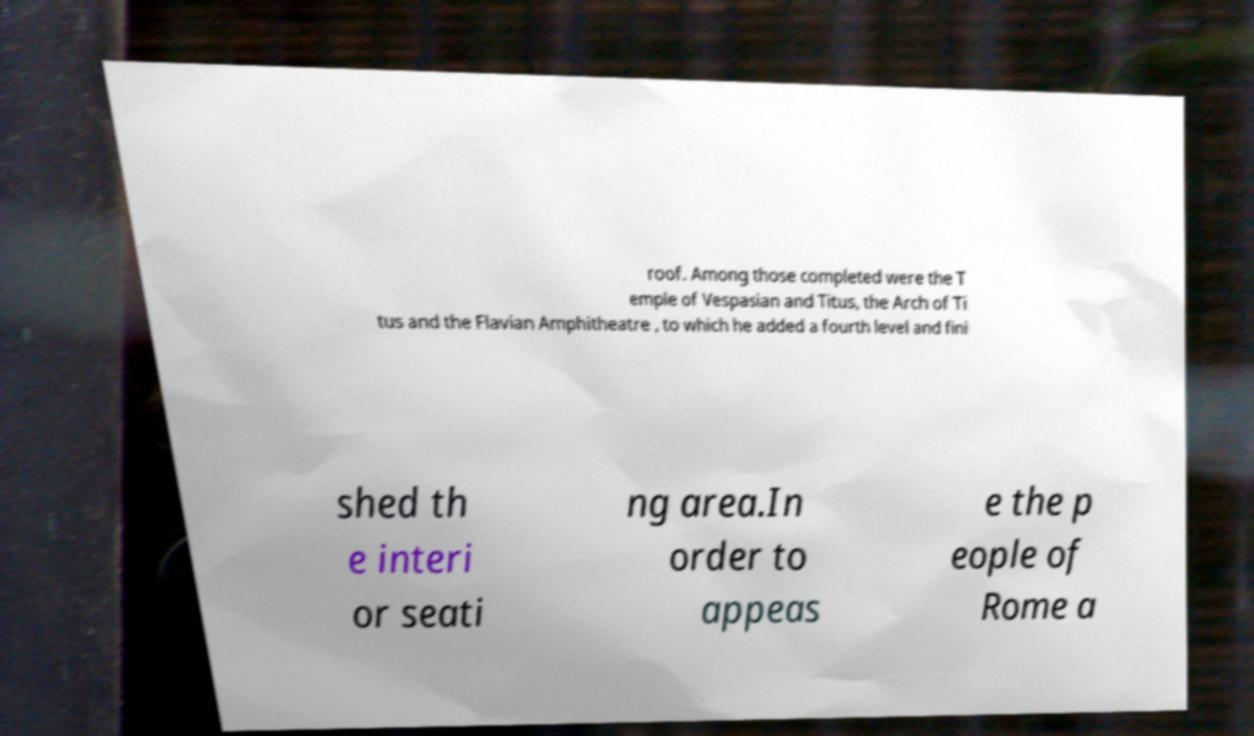Could you extract and type out the text from this image? roof. Among those completed were the T emple of Vespasian and Titus, the Arch of Ti tus and the Flavian Amphitheatre , to which he added a fourth level and fini shed th e interi or seati ng area.In order to appeas e the p eople of Rome a 